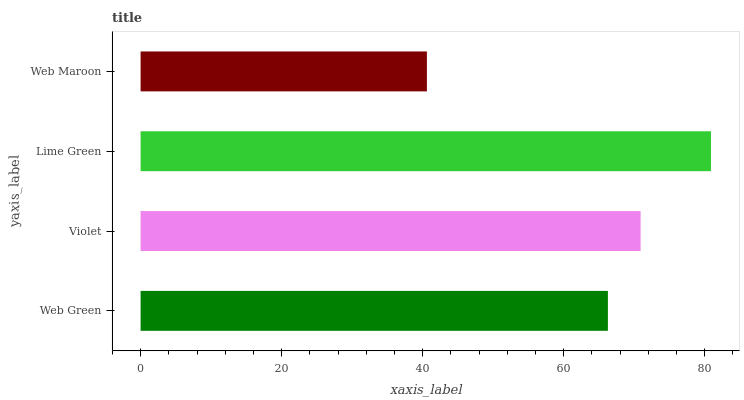Is Web Maroon the minimum?
Answer yes or no. Yes. Is Lime Green the maximum?
Answer yes or no. Yes. Is Violet the minimum?
Answer yes or no. No. Is Violet the maximum?
Answer yes or no. No. Is Violet greater than Web Green?
Answer yes or no. Yes. Is Web Green less than Violet?
Answer yes or no. Yes. Is Web Green greater than Violet?
Answer yes or no. No. Is Violet less than Web Green?
Answer yes or no. No. Is Violet the high median?
Answer yes or no. Yes. Is Web Green the low median?
Answer yes or no. Yes. Is Lime Green the high median?
Answer yes or no. No. Is Web Maroon the low median?
Answer yes or no. No. 